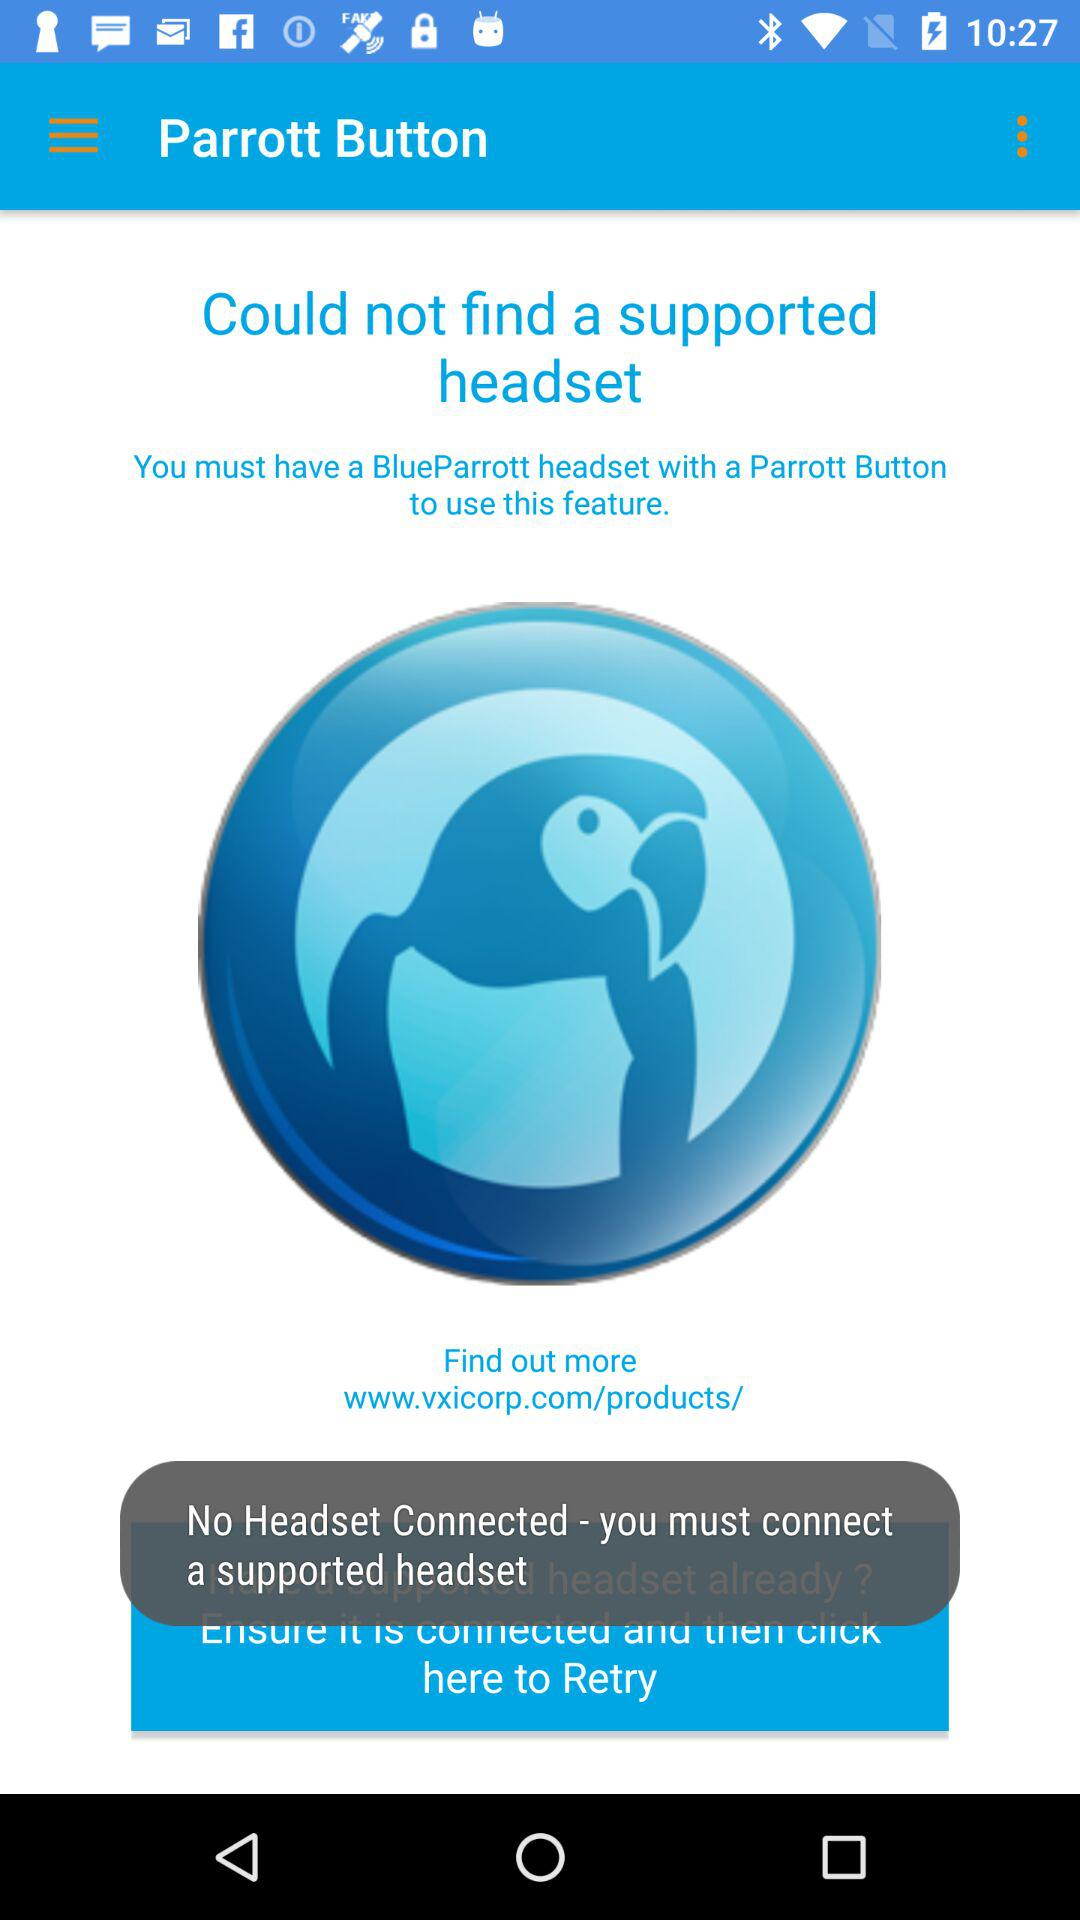What is the name of the application? The application name is "Parrott Button". 